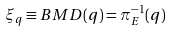<formula> <loc_0><loc_0><loc_500><loc_500>\xi _ { q } \equiv B M D ( q ) = \pi _ { E } ^ { - 1 } ( q )</formula> 